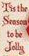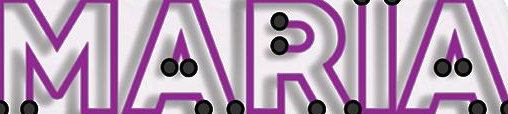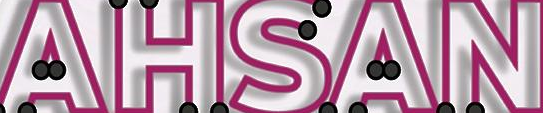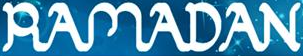Read the text from these images in sequence, separated by a semicolon. #; MARIA; AHSAN; RAMADAN 